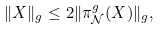Convert formula to latex. <formula><loc_0><loc_0><loc_500><loc_500>\| X \| _ { g } \leq 2 \| \pi _ { \mathcal { N } } ^ { g } ( X ) \| _ { g } ,</formula> 